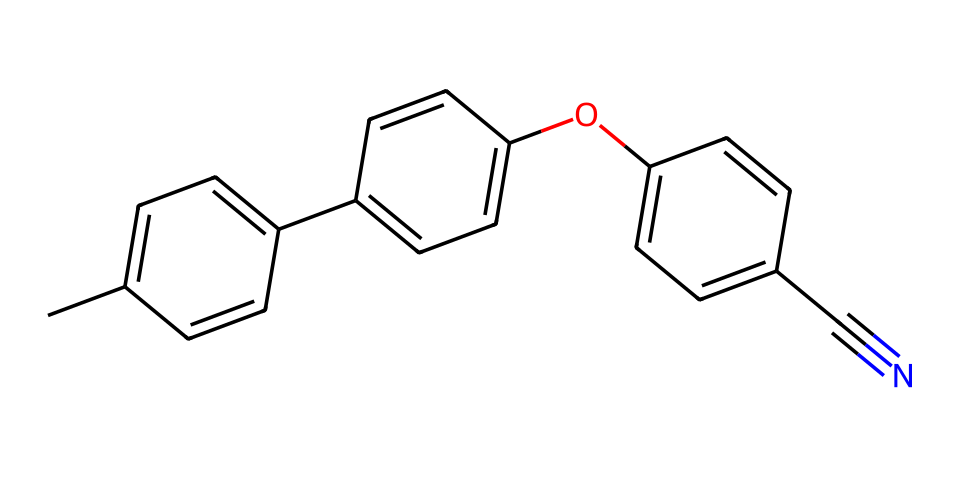What is the total number of carbon atoms in this structure? By analyzing the SMILES representation, I can count the number of 'C' characters that indicate carbon atoms. There are 12 occurrences of 'C', which gives the total number of carbon atoms in the structure.
Answer: 12 How many rings are present in this chemical structure? Observing the chemical, I can identify that there are three distinct cyclic structures due to the presence of the numbered '1' and '2' in the SMILES notation, indicating the start and end of rings. Therefore, the total ring count is three.
Answer: 3 What functional group is visible in this chemical? The presence of 'O' in the structure indicates a functional group, specifically an ether (due to the oxygen between carbon atoms). The 'C' connected to 'O' also confirms this.
Answer: ether Does the presence of the cyano group influence the overall polarity of this molecule? The cyano group (-C#N) introduces a significant dipole moment due to the highly electronegative nitrogen atom and its linear structure, which increases polarity. This influences how the molecule interacts in a liquid crystal display.
Answer: yes What type of liquid crystal does this compound mostly relate to? Given the structural characteristics, particularly the arrangement of aromatic rings, this compound is classified as a mesogenic liquid crystal, suitable for LCD applications.
Answer: mesogenic Is this compound likely to be soluble in water? The hydrophobic nature of the multiple aromatic rings and the materials implies limited polarity, suggesting that it will lack solubility in water, which is typically polar.
Answer: no 